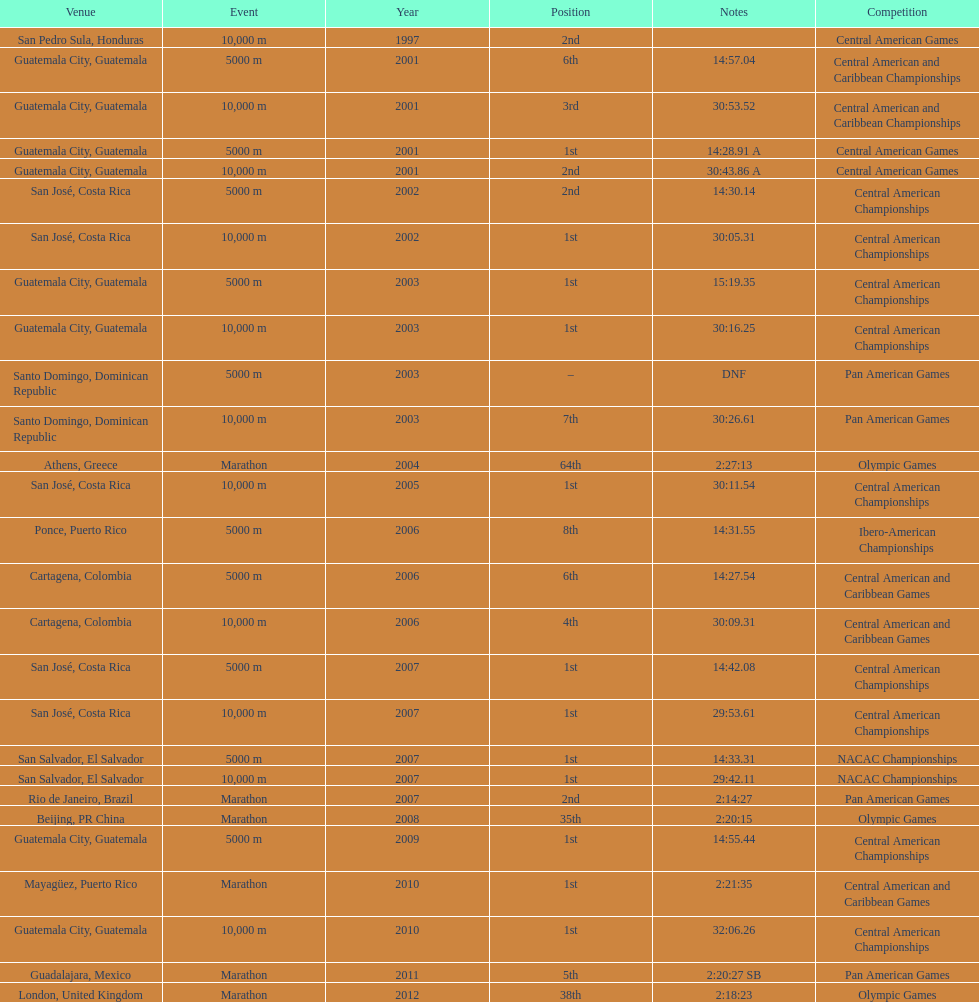How many times have they participated in competitions in guatemala? 5. 